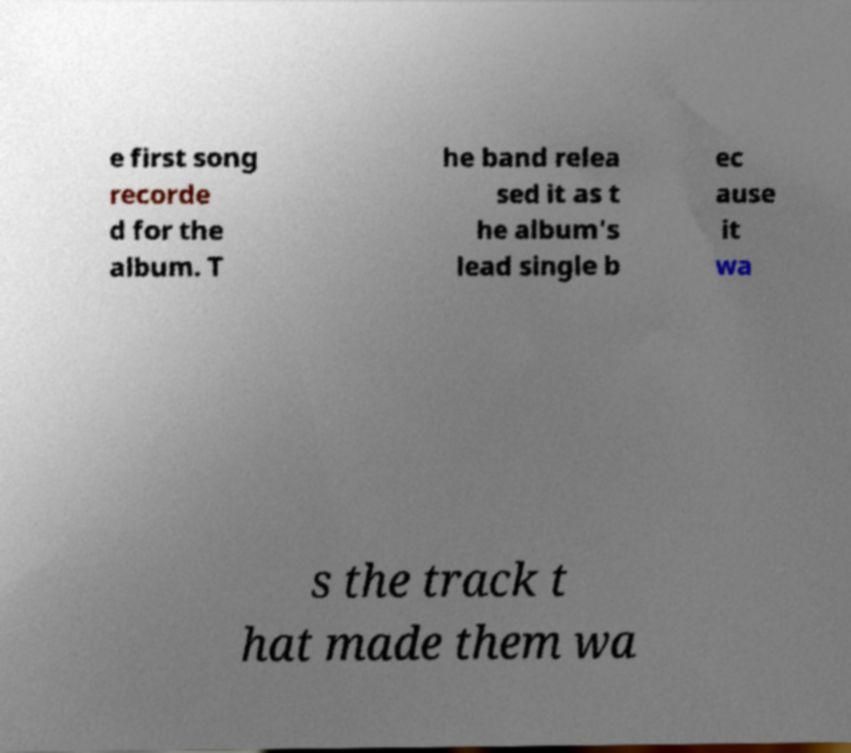Can you accurately transcribe the text from the provided image for me? e first song recorde d for the album. T he band relea sed it as t he album's lead single b ec ause it wa s the track t hat made them wa 